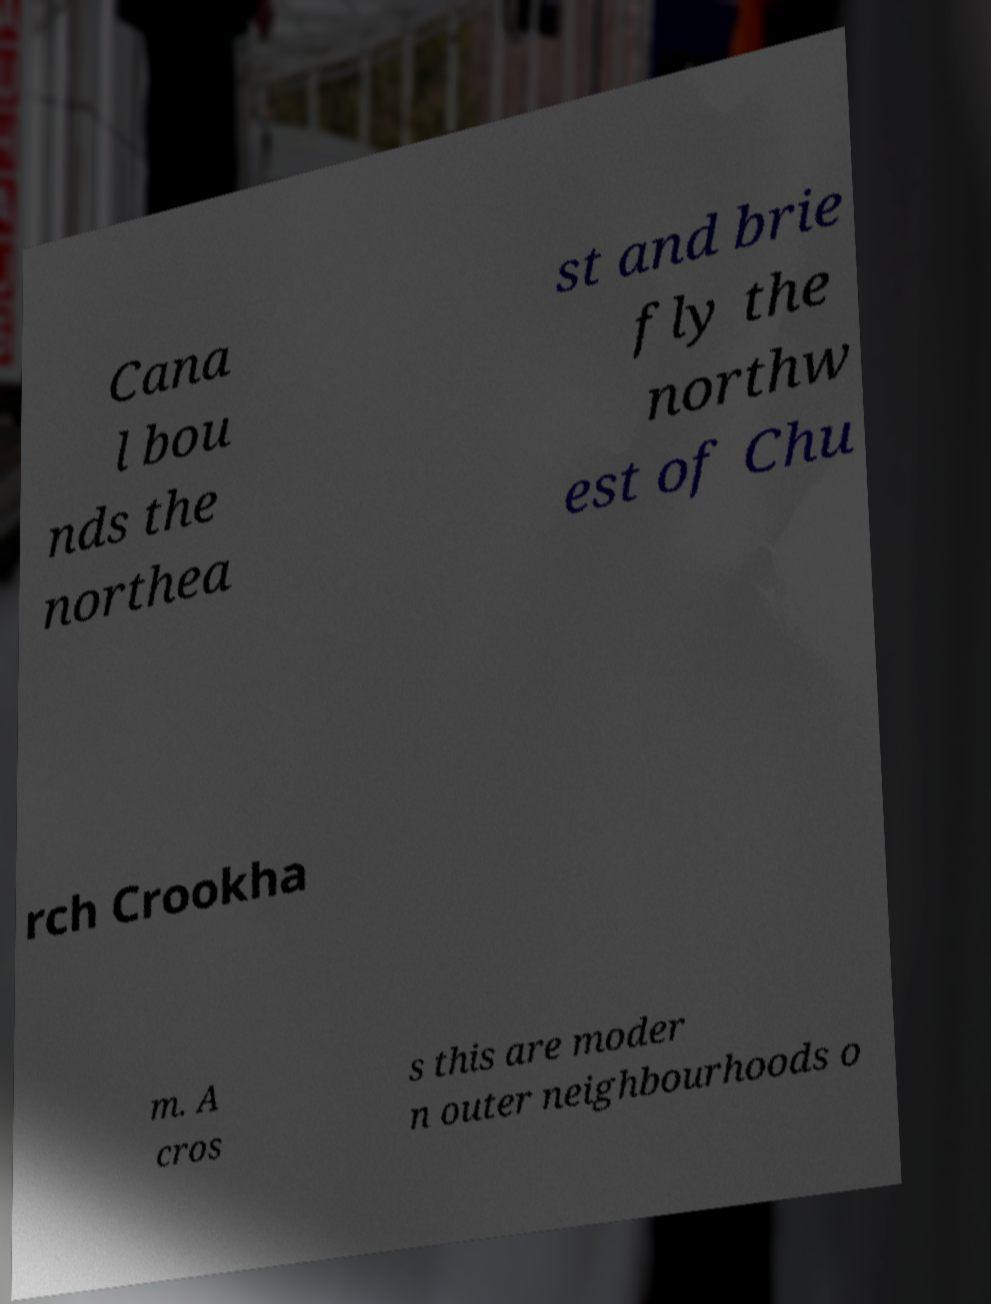For documentation purposes, I need the text within this image transcribed. Could you provide that? Cana l bou nds the northea st and brie fly the northw est of Chu rch Crookha m. A cros s this are moder n outer neighbourhoods o 